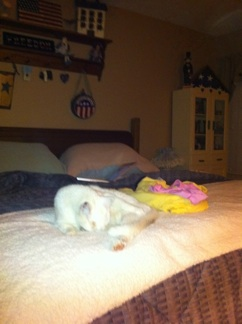Where is my cat? Your cat is lying comfortably on the bed, near some colorful items. 